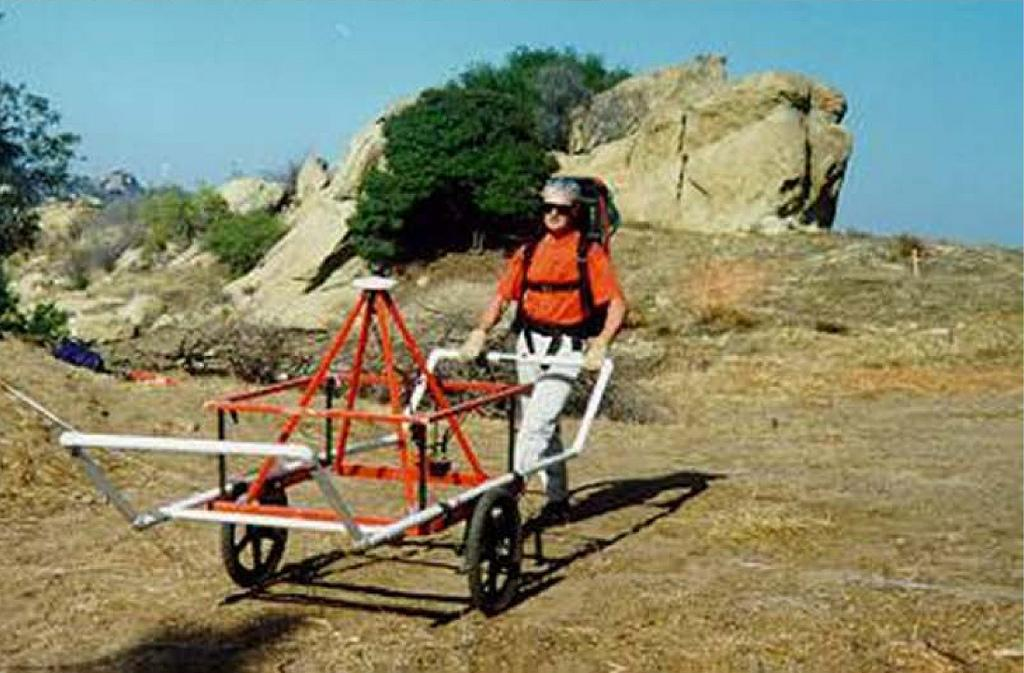What is the main object in the image? There is a trolley in the image. Who is present in the image? A person carrying a bag is visible in the image. What type of natural elements can be seen in the image? There are rocks, plants, trees, and grass present in the image. What can be seen in the background of the image? The sky is visible in the background of the image. What type of powder can be seen covering the rocks in the image? There is no powder visible on the rocks in the image. Can you see a rabbit hopping near the trees in the image? There is no rabbit present in the image. 